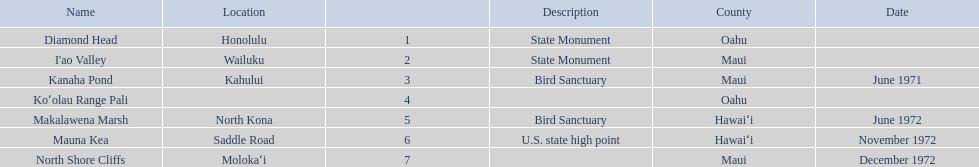How many dates are in 1972? 3. 